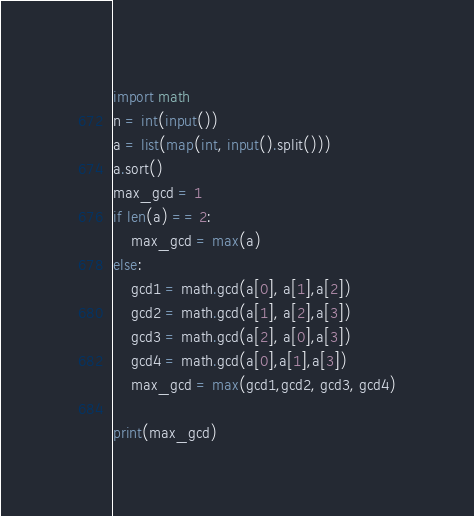Convert code to text. <code><loc_0><loc_0><loc_500><loc_500><_Python_>import math
n = int(input())
a = list(map(int, input().split()))
a.sort()
max_gcd = 1
if len(a) == 2:
    max_gcd = max(a)
else:
    gcd1 = math.gcd(a[0], a[1],a[2])
    gcd2 = math.gcd(a[1], a[2],a[3])
    gcd3 = math.gcd(a[2], a[0],a[3])
    gcd4 = math.gcd(a[0],a[1],a[3])
    max_gcd = max(gcd1,gcd2, gcd3, gcd4)

print(max_gcd)</code> 